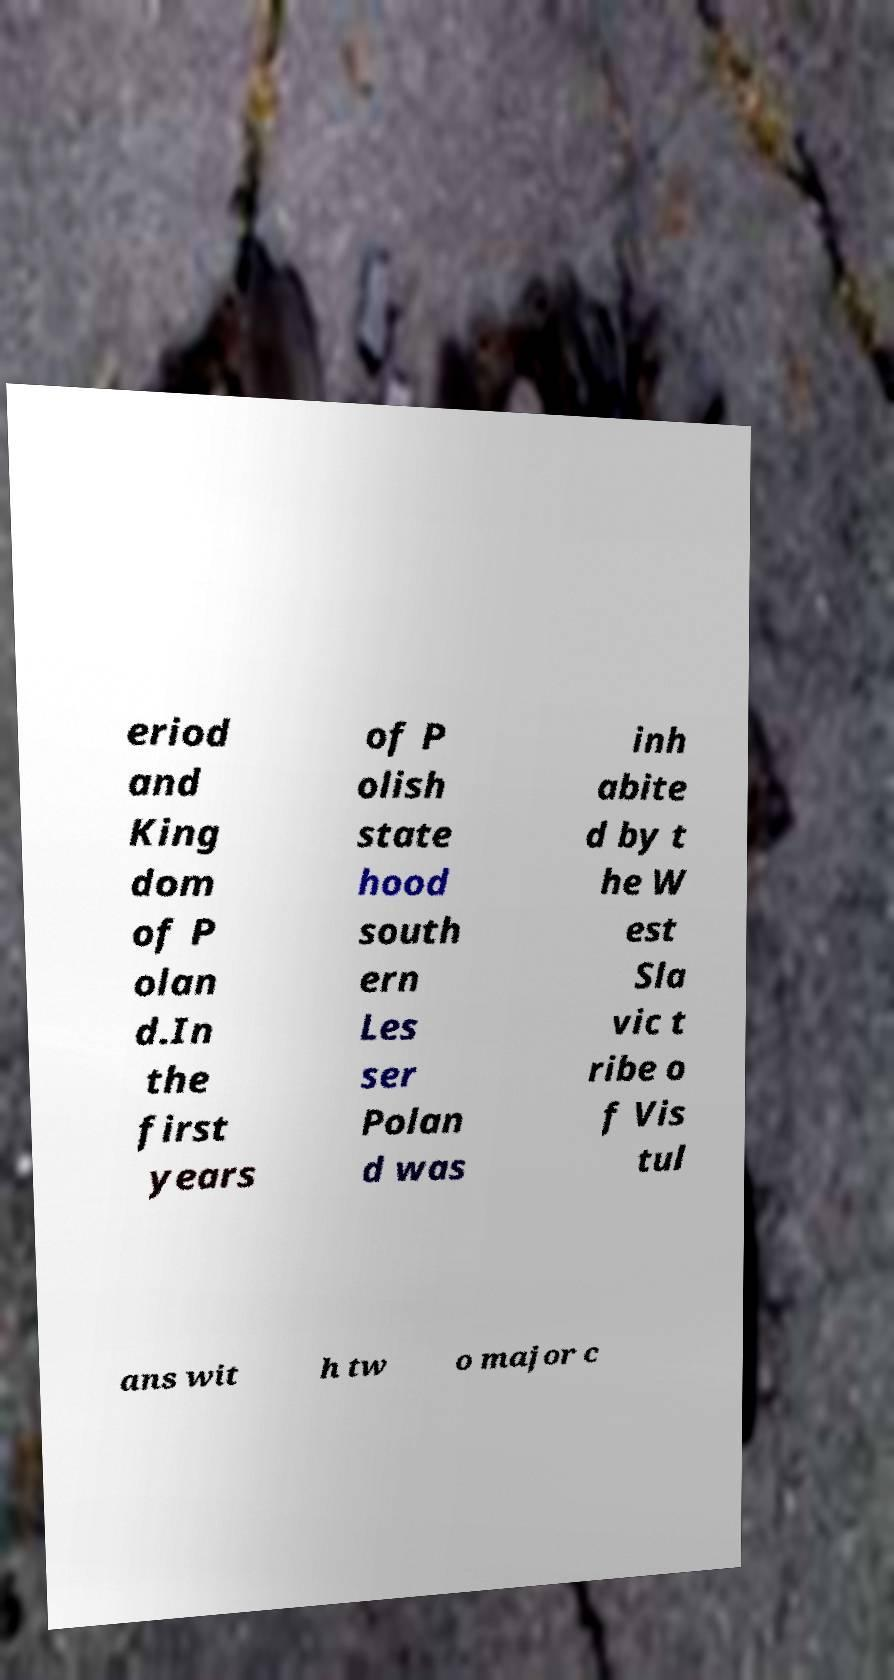Can you read and provide the text displayed in the image?This photo seems to have some interesting text. Can you extract and type it out for me? eriod and King dom of P olan d.In the first years of P olish state hood south ern Les ser Polan d was inh abite d by t he W est Sla vic t ribe o f Vis tul ans wit h tw o major c 